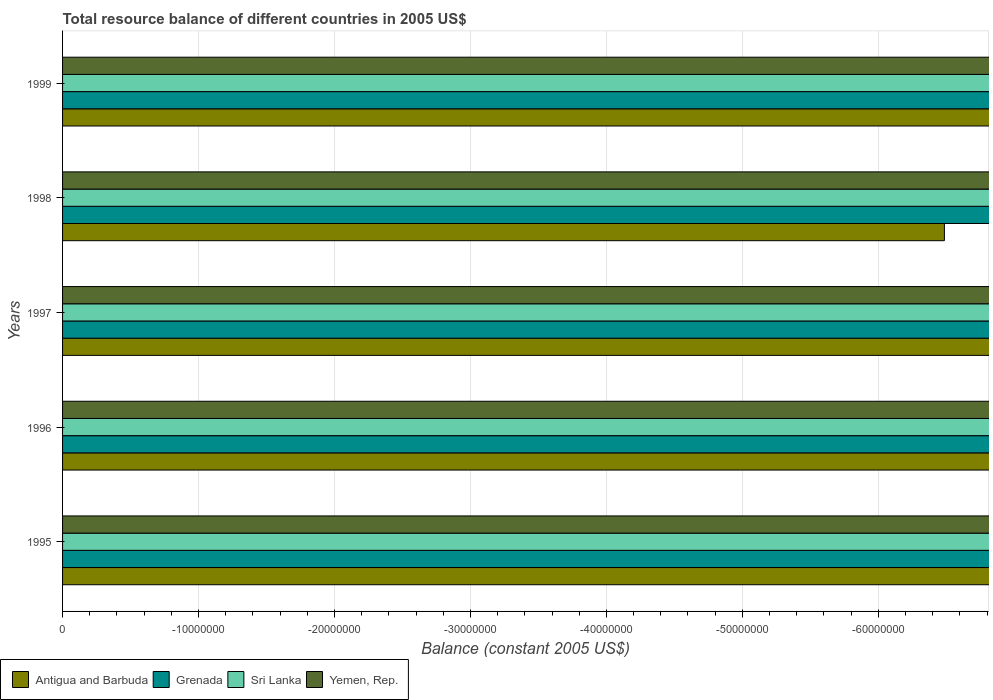How many bars are there on the 2nd tick from the top?
Provide a succinct answer. 0. What is the total resource balance in Sri Lanka in 1995?
Make the answer very short. 0. What is the total total resource balance in Yemen, Rep. in the graph?
Your response must be concise. 0. In how many years, is the total resource balance in Grenada greater than -34000000 US$?
Your answer should be compact. 0. In how many years, is the total resource balance in Antigua and Barbuda greater than the average total resource balance in Antigua and Barbuda taken over all years?
Your answer should be very brief. 0. Is it the case that in every year, the sum of the total resource balance in Yemen, Rep. and total resource balance in Antigua and Barbuda is greater than the total resource balance in Grenada?
Offer a very short reply. No. Are all the bars in the graph horizontal?
Ensure brevity in your answer.  Yes. What is the difference between two consecutive major ticks on the X-axis?
Provide a succinct answer. 1.00e+07. Are the values on the major ticks of X-axis written in scientific E-notation?
Offer a terse response. No. Does the graph contain any zero values?
Provide a short and direct response. Yes. Does the graph contain grids?
Keep it short and to the point. Yes. What is the title of the graph?
Make the answer very short. Total resource balance of different countries in 2005 US$. Does "Czech Republic" appear as one of the legend labels in the graph?
Your answer should be very brief. No. What is the label or title of the X-axis?
Your response must be concise. Balance (constant 2005 US$). What is the Balance (constant 2005 US$) in Sri Lanka in 1995?
Provide a succinct answer. 0. What is the Balance (constant 2005 US$) of Yemen, Rep. in 1995?
Keep it short and to the point. 0. What is the Balance (constant 2005 US$) in Sri Lanka in 1996?
Make the answer very short. 0. What is the Balance (constant 2005 US$) of Yemen, Rep. in 1996?
Keep it short and to the point. 0. What is the Balance (constant 2005 US$) of Grenada in 1997?
Keep it short and to the point. 0. What is the Balance (constant 2005 US$) of Antigua and Barbuda in 1999?
Make the answer very short. 0. What is the Balance (constant 2005 US$) in Sri Lanka in 1999?
Make the answer very short. 0. What is the Balance (constant 2005 US$) of Yemen, Rep. in 1999?
Provide a short and direct response. 0. What is the total Balance (constant 2005 US$) of Antigua and Barbuda in the graph?
Ensure brevity in your answer.  0. What is the total Balance (constant 2005 US$) in Grenada in the graph?
Offer a very short reply. 0. What is the total Balance (constant 2005 US$) of Sri Lanka in the graph?
Give a very brief answer. 0. What is the average Balance (constant 2005 US$) of Sri Lanka per year?
Your answer should be compact. 0. What is the average Balance (constant 2005 US$) in Yemen, Rep. per year?
Provide a succinct answer. 0. 